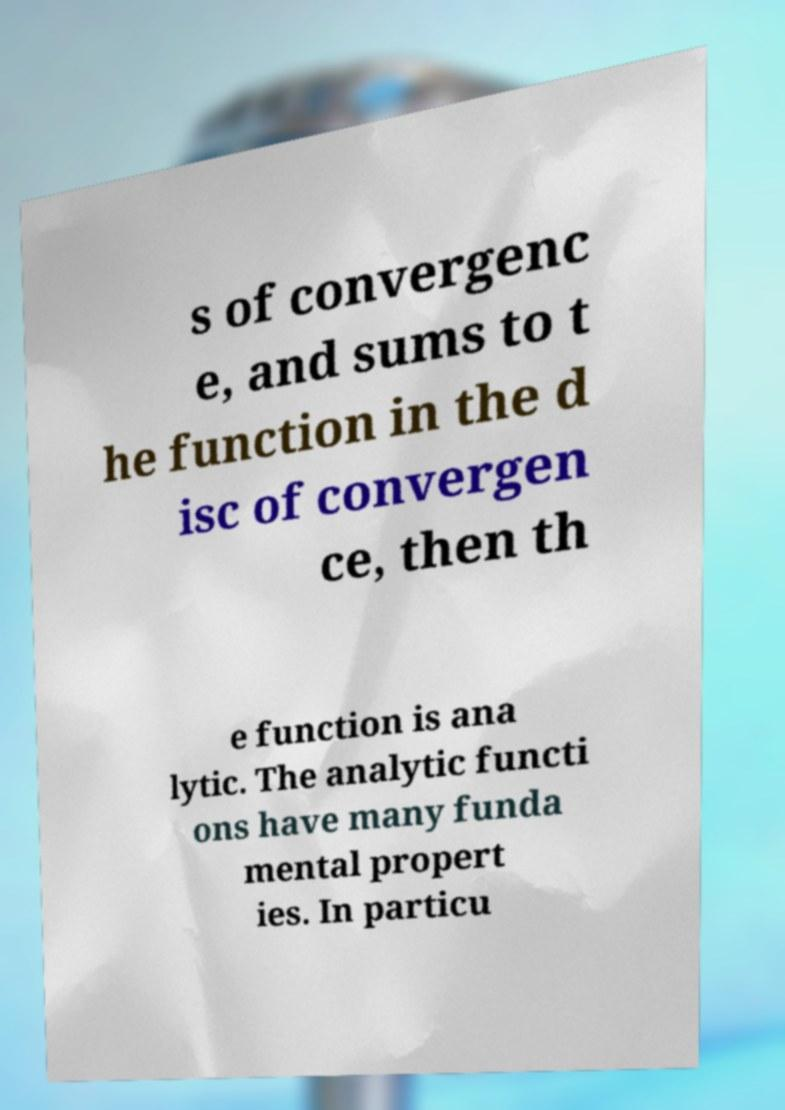Please read and relay the text visible in this image. What does it say? s of convergenc e, and sums to t he function in the d isc of convergen ce, then th e function is ana lytic. The analytic functi ons have many funda mental propert ies. In particu 